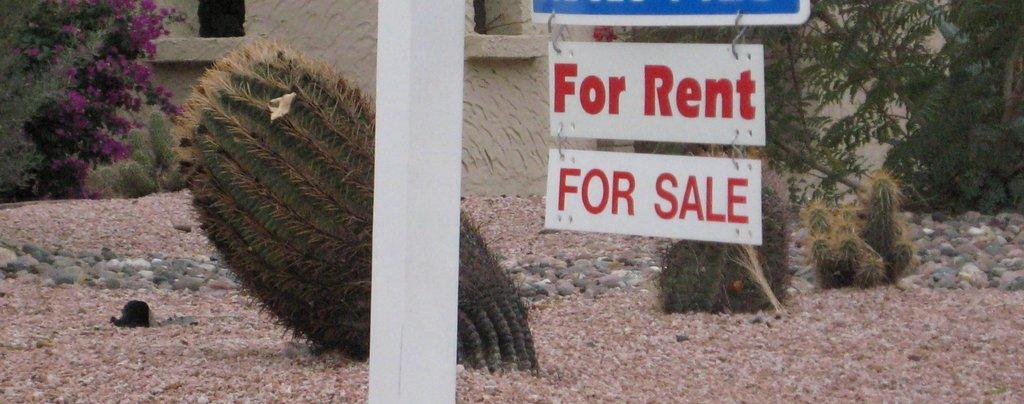Please provide a concise description of this image. In this image few cactus plants are on the land having some stones on it. Top of image few boards are hanged one below the other. Middle of image there is a pole. Left top of image there are few plants having flowers. Right side there is a plant. Behind it there is a wall. 